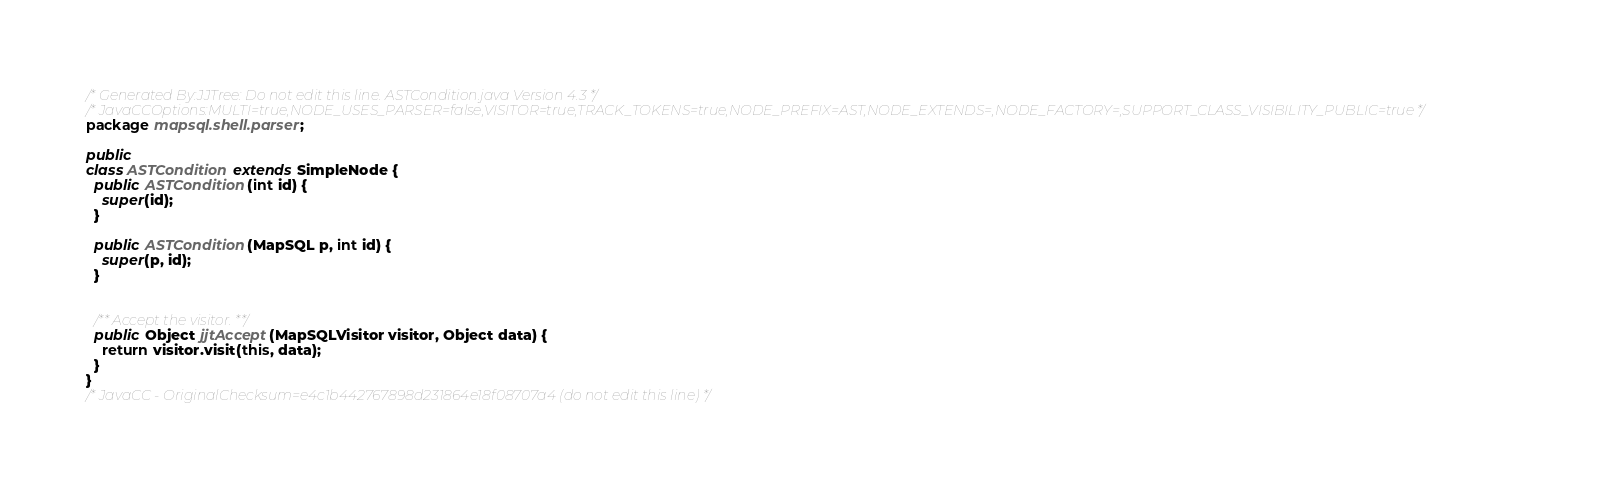<code> <loc_0><loc_0><loc_500><loc_500><_Java_>/* Generated By:JJTree: Do not edit this line. ASTCondition.java Version 4.3 */
/* JavaCCOptions:MULTI=true,NODE_USES_PARSER=false,VISITOR=true,TRACK_TOKENS=true,NODE_PREFIX=AST,NODE_EXTENDS=,NODE_FACTORY=,SUPPORT_CLASS_VISIBILITY_PUBLIC=true */
package mapsql.shell.parser;

public
class ASTCondition extends SimpleNode {
  public ASTCondition(int id) {
    super(id);
  }

  public ASTCondition(MapSQL p, int id) {
    super(p, id);
  }


  /** Accept the visitor. **/
  public Object jjtAccept(MapSQLVisitor visitor, Object data) {
    return visitor.visit(this, data);
  }
}
/* JavaCC - OriginalChecksum=e4c1b442767898d231864e18f08707a4 (do not edit this line) */
</code> 